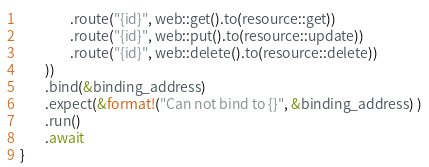Convert code to text. <code><loc_0><loc_0><loc_500><loc_500><_Rust_>                .route("{id}", web::get().to(resource::get))
                .route("{id}", web::put().to(resource::update))
                .route("{id}", web::delete().to(resource::delete))
        ))
        .bind(&binding_address)
        .expect(&format!("Can not bind to {}", &binding_address) )
        .run()
        .await
}
</code> 